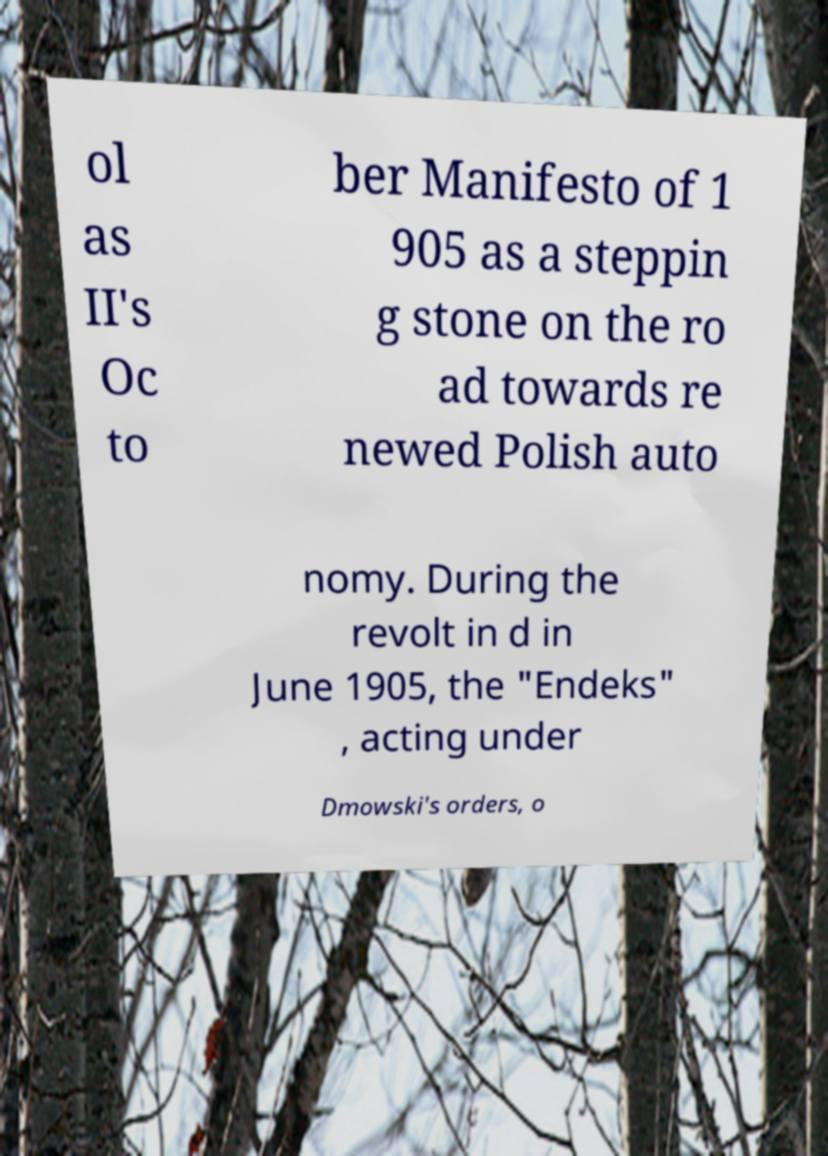There's text embedded in this image that I need extracted. Can you transcribe it verbatim? ol as II's Oc to ber Manifesto of 1 905 as a steppin g stone on the ro ad towards re newed Polish auto nomy. During the revolt in d in June 1905, the "Endeks" , acting under Dmowski's orders, o 